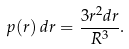Convert formula to latex. <formula><loc_0><loc_0><loc_500><loc_500>p ( r ) \, d r = \frac { 3 r ^ { 2 } d r } { R ^ { 3 } } .</formula> 